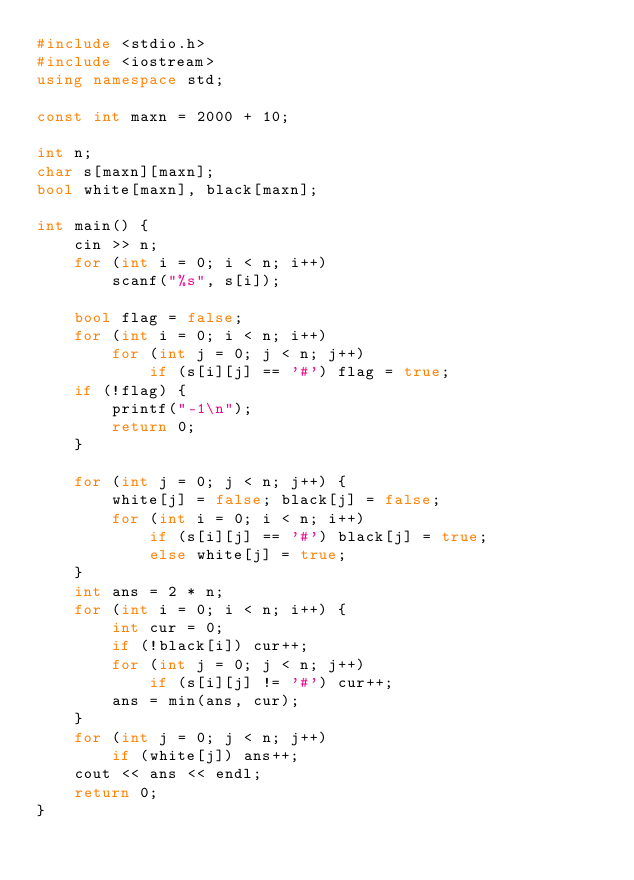Convert code to text. <code><loc_0><loc_0><loc_500><loc_500><_C++_>#include <stdio.h>
#include <iostream>
using namespace std;

const int maxn = 2000 + 10;

int n;
char s[maxn][maxn];
bool white[maxn], black[maxn];

int main() {
    cin >> n;
    for (int i = 0; i < n; i++)    
        scanf("%s", s[i]);
    
    bool flag = false;
    for (int i = 0; i < n; i++) 
        for (int j = 0; j < n; j++) 
            if (s[i][j] == '#') flag = true;
    if (!flag) {
        printf("-1\n");
        return 0;
    }

    for (int j = 0; j < n; j++) {
        white[j] = false; black[j] = false;
        for (int i = 0; i < n; i++) 
            if (s[i][j] == '#') black[j] = true;
            else white[j] = true;
    }
    int ans = 2 * n;
    for (int i = 0; i < n; i++) {
        int cur = 0;
        if (!black[i]) cur++;
        for (int j = 0; j < n; j++) 
            if (s[i][j] != '#') cur++;
        ans = min(ans, cur);
    }
    for (int j = 0; j < n; j++) 
        if (white[j]) ans++;
    cout << ans << endl;
    return 0;
}</code> 